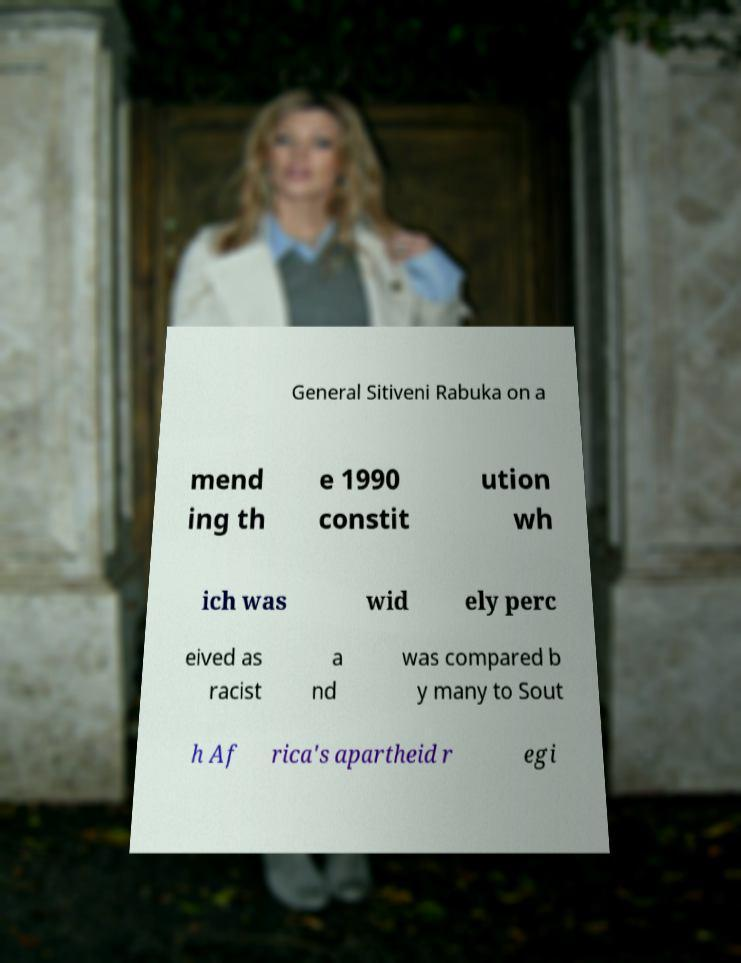Can you read and provide the text displayed in the image?This photo seems to have some interesting text. Can you extract and type it out for me? General Sitiveni Rabuka on a mend ing th e 1990 constit ution wh ich was wid ely perc eived as racist a nd was compared b y many to Sout h Af rica's apartheid r egi 